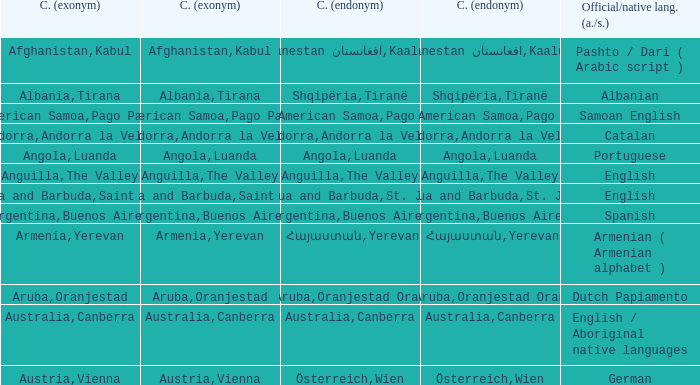What official or native languages are spoken in the country whose capital city is Canberra? English / Aboriginal native languages. 